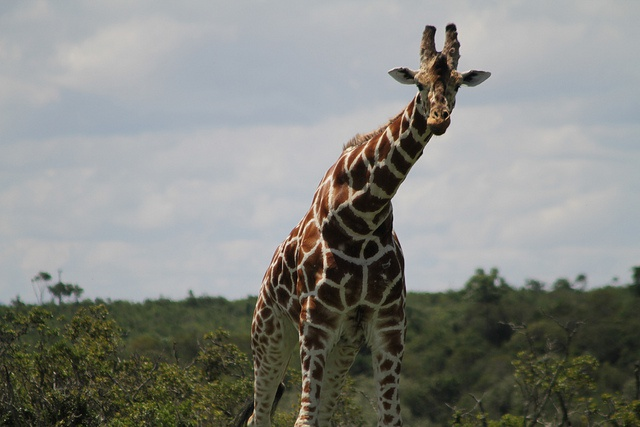Describe the objects in this image and their specific colors. I can see a giraffe in darkgray, black, darkgreen, gray, and maroon tones in this image. 